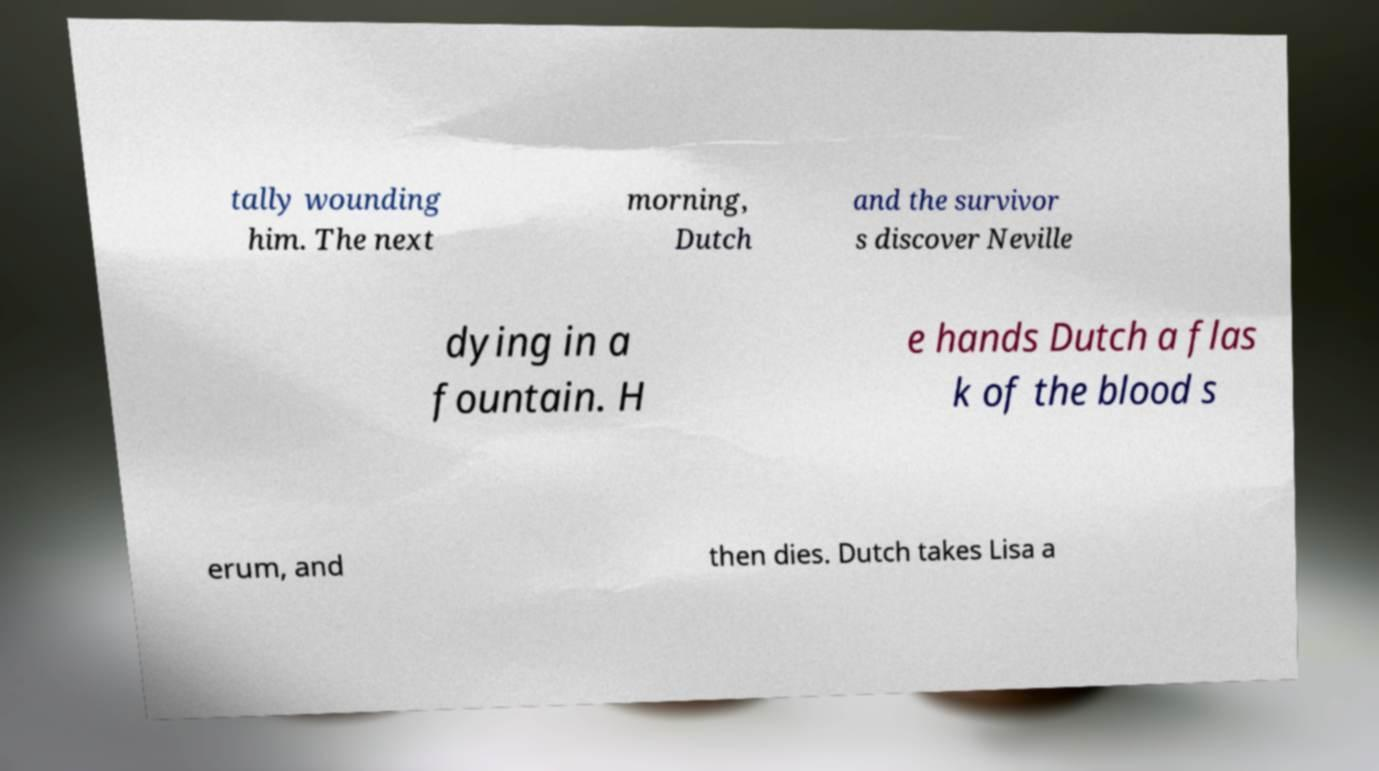Can you accurately transcribe the text from the provided image for me? tally wounding him. The next morning, Dutch and the survivor s discover Neville dying in a fountain. H e hands Dutch a flas k of the blood s erum, and then dies. Dutch takes Lisa a 